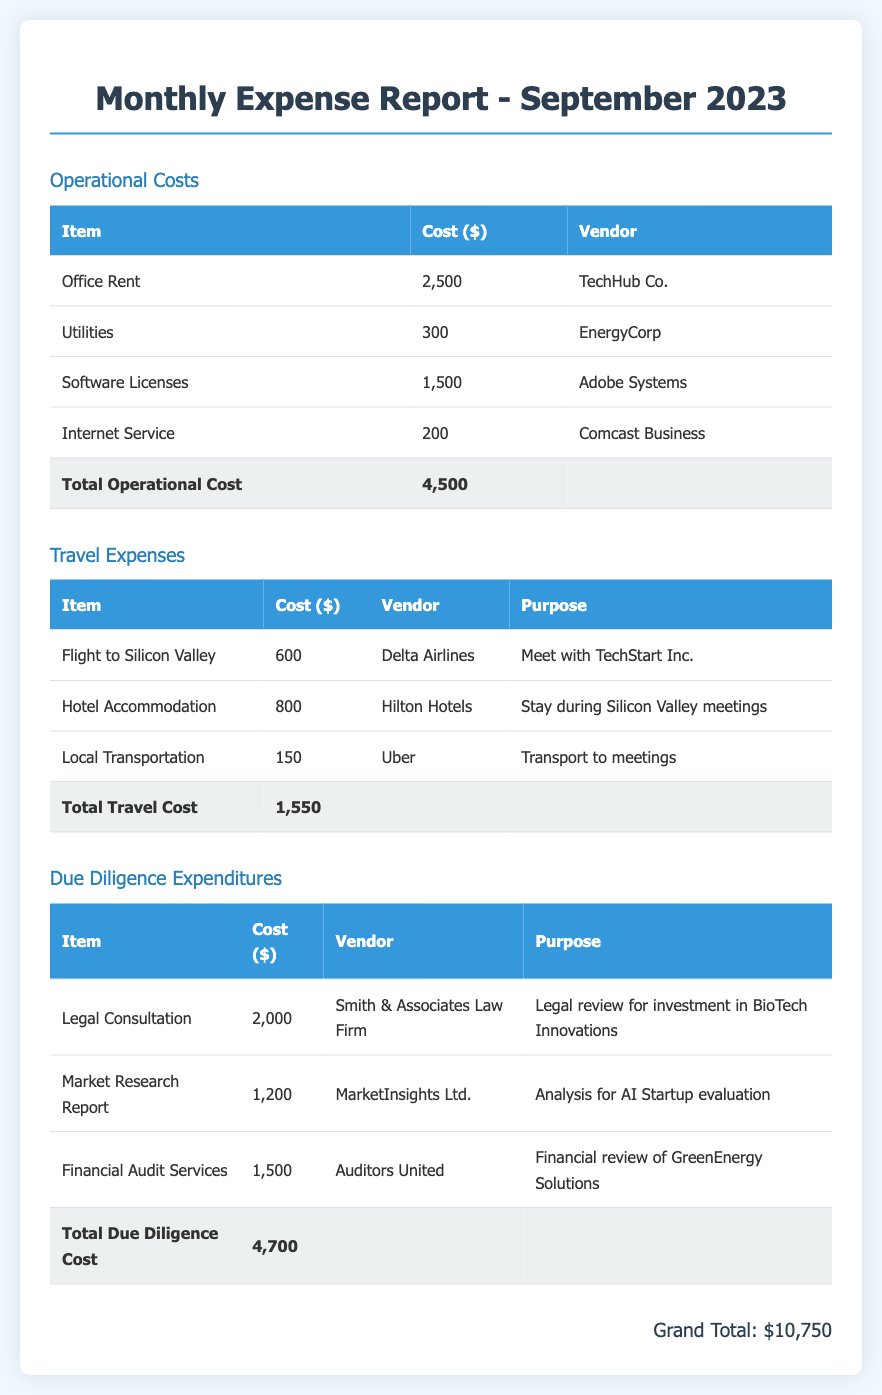What is the total operational cost? The total operational cost is listed at the bottom of the operational costs section as $4,500.
Answer: $4,500 Who provided the legal consultation? The vendor for the legal consultation is noted as Smith & Associates Law Firm in the due diligence expenditures section.
Answer: Smith & Associates Law Firm How much was spent on travel expenses? The total travel cost is summarized at the end of the travel expenses section, which is $1,550.
Answer: $1,550 What was the purpose of the flight to Silicon Valley? The purpose for this travel expense is stated as "Meet with TechStart Inc." in the travel expenses section.
Answer: Meet with TechStart Inc What is the grand total of all expenses for September 2023? The grand total is listed at the bottom of the document, which combines all operational, travel, and due diligence costs to equal $10,750.
Answer: $10,750 How much did the market research report cost? The cost of the market research report is specified as $1,200 under the due diligence expenditures section.
Answer: $1,200 What vendor provided the software licenses? The software licenses were provided by Adobe Systems, as indicated in the operational costs section.
Answer: Adobe Systems What was the cost of hotel accommodation? The hotel accommodation cost is present in the travel expenses section as $800.
Answer: $800 